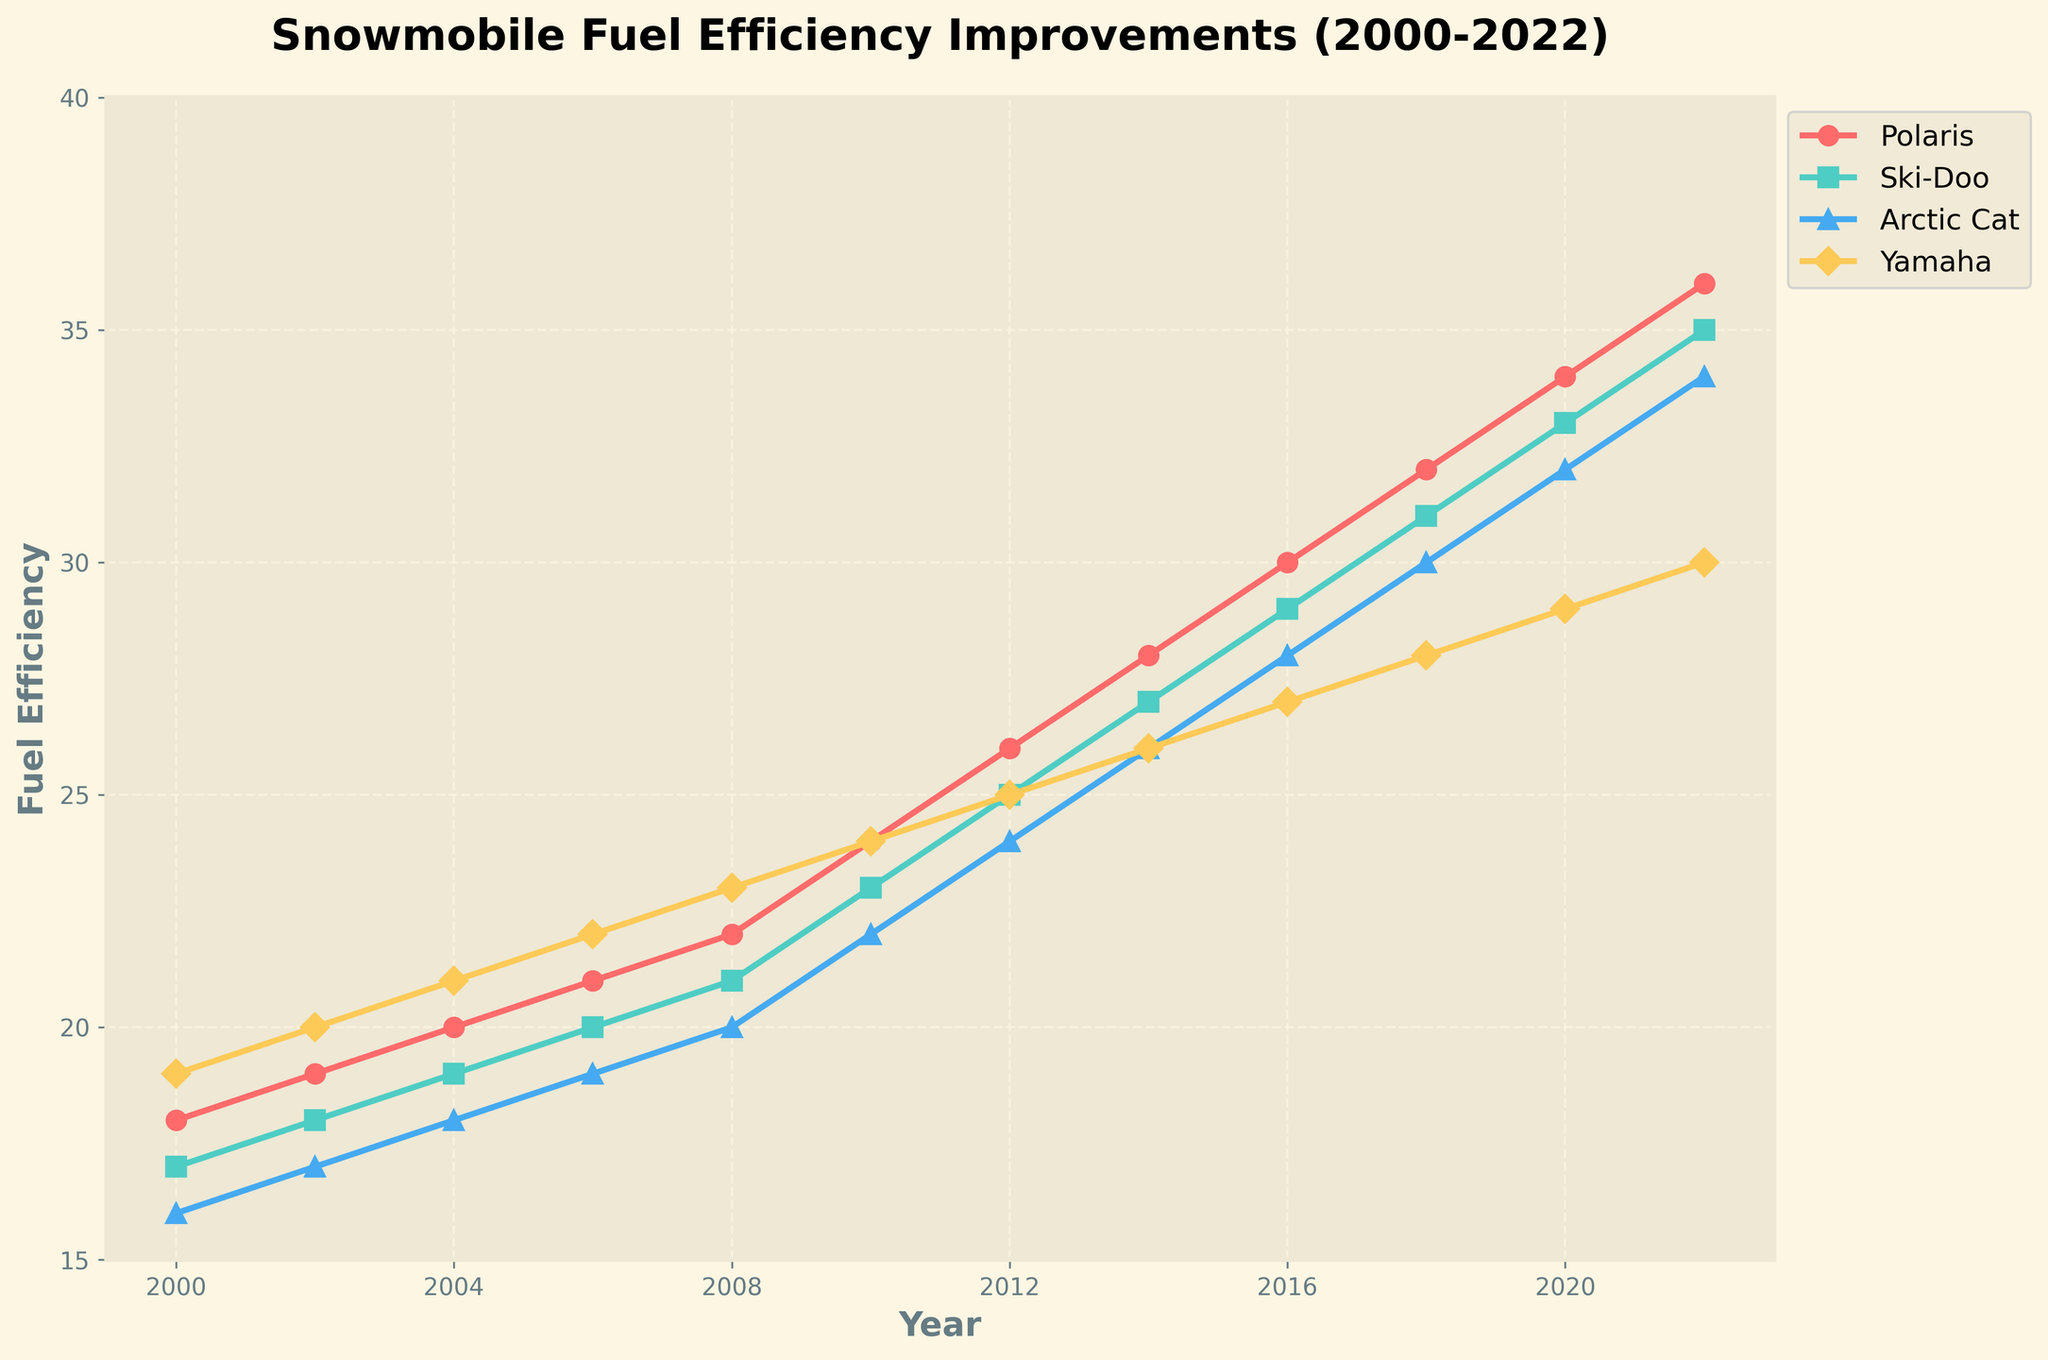Which manufacturer had the highest fuel efficiency in 2012? Look at the 2012 mark on the x-axis, then compare the heights of the markers for each manufacturer. Polaris is at 26, Ski-Doo is at 25, Arctic Cat is at 24, and Yamaha is at 25. Polaris has the highest value.
Answer: Polaris How much did Yamaha's fuel efficiency improve from 2000 to 2022? Find Yamaha's values in 2000 and 2022. In 2000 it was 19, in 2022 it was 30. Subtract the 2000 value from the 2022 value: 30 - 19 = 11.
Answer: 11 Which two manufacturers had the same fuel efficiency in 2014? Find the 2014 data points. Polaris is 28, Ski-Doo is 27, Arctic Cat is 26, and Yamaha is 26. Arctic Cat and Yamaha have the same value.
Answer: Arctic Cat and Yamaha What was the average fuel efficiency of all manufacturers in 2010? Sum the 2010 values for each manufacturer (Polaris: 24, Ski-Doo: 23, Arctic Cat: 22, Yamaha: 24). Total is 24 + 23 + 22 + 24 = 93. There are 4 manufacturers, so divide by 4: 93 / 4 = 23.25.
Answer: 23.25 Which manufacturer had the least improvement in fuel efficiency from 2000 to 2022? Calculate the improvements for each manufacturer (subtract 2000 value from 2022 value). Polaris: 36 - 18 = 18, Ski-Doo: 35 - 17 = 18, Arctic Cat: 34 - 16 = 18, Yamaha: 30 - 19 = 11. Yamaha had the least improvement.
Answer: Yamaha In which year did Polaris and Arctic Cat have the same fuel efficiency? Look for the intersection points between Polaris and Arctic Cat's lines. In 2006, both have a fuel efficiency of 21.
Answer: 2006 Between 2012 and 2022, which manufacturer had the most steady improvement in fuel efficiency? Calculate the differences for each two-year interval for each manufacturer between 2012 and 2022, and see which has consistent increments. Polaris: 28-26, 30-28, 32-30, 34-32, 36-34 (all increments by 2). Other manufacturers had varying increments. Polaris shows steady improvements.
Answer: Polaris 